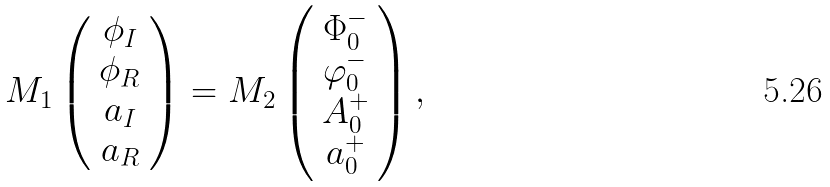Convert formula to latex. <formula><loc_0><loc_0><loc_500><loc_500>M _ { 1 } \left ( \begin{array} { c } \phi _ { I } \\ \phi _ { R } \\ a _ { I } \\ a _ { R } \end{array} \right ) = M _ { 2 } \left ( \begin{array} { c } \Phi _ { 0 } ^ { - } \\ \varphi _ { 0 } ^ { - } \\ A _ { 0 } ^ { + } \\ a _ { 0 } ^ { + } \end{array} \right ) ,</formula> 